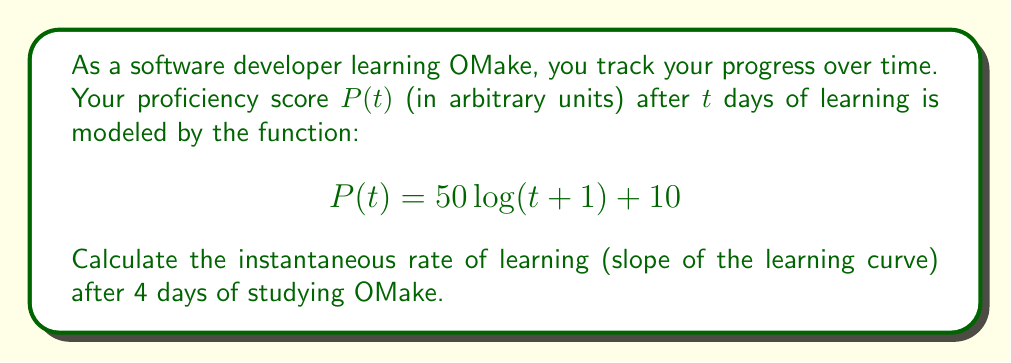Could you help me with this problem? To find the instantaneous rate of learning (slope of the learning curve) at t = 4 days, we need to calculate the derivative of P(t) and evaluate it at t = 4.

Step 1: Find the derivative of P(t)
$$P(t) = 50\log(t+1) + 10$$
$$P'(t) = 50 \cdot \frac{d}{dt}[\log(t+1)]$$
Using the chain rule:
$$P'(t) = 50 \cdot \frac{1}{t+1} \cdot \frac{d}{dt}[t+1]$$
$$P'(t) = 50 \cdot \frac{1}{t+1} \cdot 1$$
$$P'(t) = \frac{50}{t+1}$$

Step 2: Evaluate P'(t) at t = 4
$$P'(4) = \frac{50}{4+1} = \frac{50}{5} = 10$$

The instantaneous rate of learning after 4 days is 10 units per day.
Answer: 10 units/day 